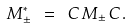<formula> <loc_0><loc_0><loc_500><loc_500>M ^ { * } _ { \pm } \ = \ C \, M _ { \pm } \, C \, .</formula> 